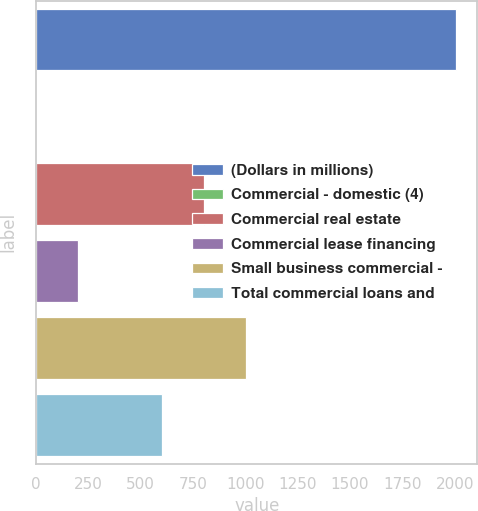Convert chart. <chart><loc_0><loc_0><loc_500><loc_500><bar_chart><fcel>(Dollars in millions)<fcel>Commercial - domestic (4)<fcel>Commercial real estate<fcel>Commercial lease financing<fcel>Small business commercial -<fcel>Total commercial loans and<nl><fcel>2008<fcel>0.26<fcel>803.34<fcel>201.03<fcel>1004.11<fcel>602.57<nl></chart> 